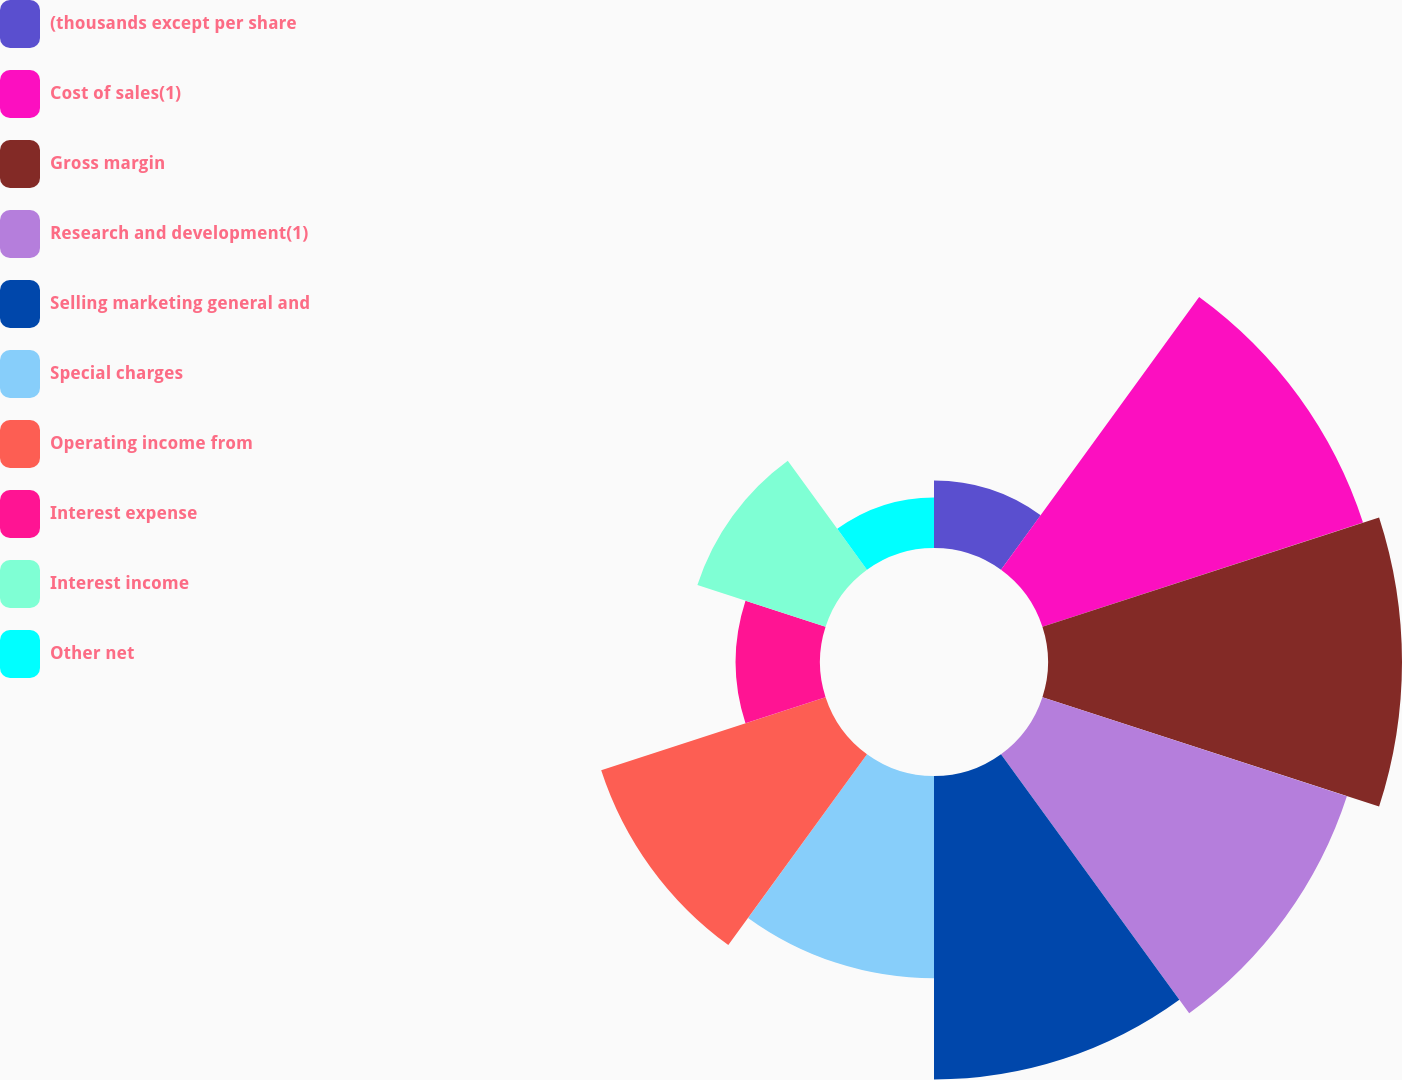Convert chart to OTSL. <chart><loc_0><loc_0><loc_500><loc_500><pie_chart><fcel>(thousands except per share<fcel>Cost of sales(1)<fcel>Gross margin<fcel>Research and development(1)<fcel>Selling marketing general and<fcel>Special charges<fcel>Operating income from<fcel>Interest expense<fcel>Interest income<fcel>Other net<nl><fcel>3.23%<fcel>16.13%<fcel>16.94%<fcel>15.32%<fcel>14.52%<fcel>9.68%<fcel>11.29%<fcel>4.03%<fcel>6.45%<fcel>2.42%<nl></chart> 